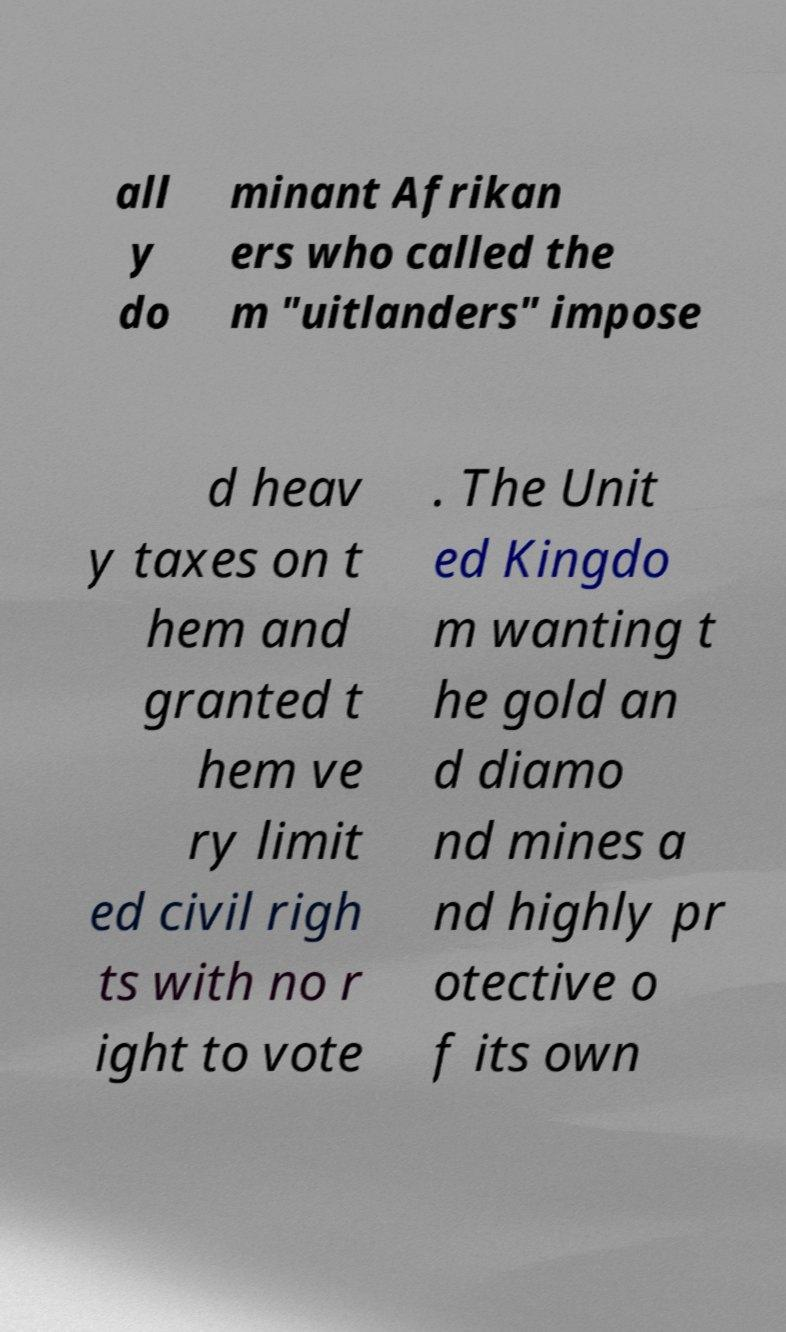Please read and relay the text visible in this image. What does it say? all y do minant Afrikan ers who called the m "uitlanders" impose d heav y taxes on t hem and granted t hem ve ry limit ed civil righ ts with no r ight to vote . The Unit ed Kingdo m wanting t he gold an d diamo nd mines a nd highly pr otective o f its own 